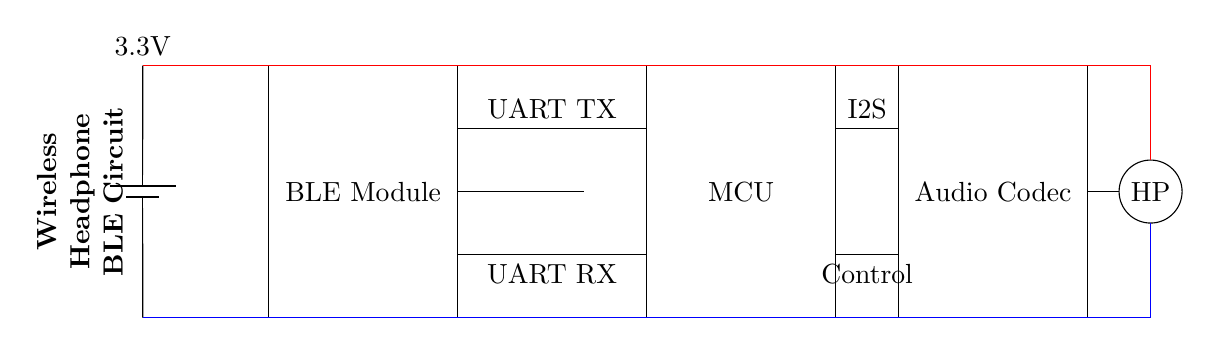What is the primary function of the BLE module? The BLE module is designed for Bluetooth Low Energy communication, allowing the device to connect wirelessly to headphones.
Answer: Bluetooth Low Energy communication What is the voltage of the power supply in the circuit? The power supply provides 3.3 volts, as indicated by the battery symbol labeled with that voltage value.
Answer: 3.3 volts How is the audio data transmitted from the MCU to the Audio Codec? The audio data is transmitted from the MCU to the Audio Codec using an I2S connection, which is represented by the line between them labeled "I2S".
Answer: I2S What type of connector is represented for the headphones? The headphone connector is depicted as a circle labeled "HP", indicating that it is a headphone jack.
Answer: Headphone jack What are the two types of data connections from the BLE module to the MCU? The BLE module connects to the MCU via UART TX for transmission and UART RX for reception, as shown by the two lines labeled accordingly.
Answer: UART TX and UART RX How is power distributed through the circuit? Power is distributed through the circuit using red lines for the positive supply and blue lines for the ground, as shown connecting all components to the power supply.
Answer: Red for positive, blue for ground What is the function of the audio codec in this circuit? The audio codec is responsible for processing the audio signals, converting digital audio to analog to drive the headphone jack.
Answer: Audio processing 